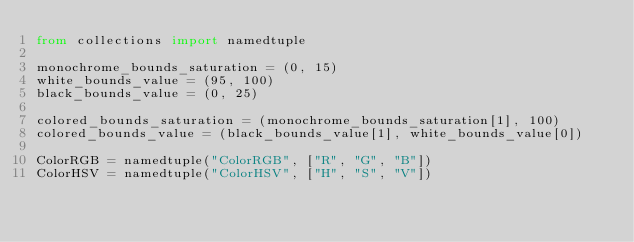Convert code to text. <code><loc_0><loc_0><loc_500><loc_500><_Python_>from collections import namedtuple

monochrome_bounds_saturation = (0, 15)
white_bounds_value = (95, 100)
black_bounds_value = (0, 25)

colored_bounds_saturation = (monochrome_bounds_saturation[1], 100)
colored_bounds_value = (black_bounds_value[1], white_bounds_value[0])

ColorRGB = namedtuple("ColorRGB", ["R", "G", "B"])
ColorHSV = namedtuple("ColorHSV", ["H", "S", "V"])
</code> 